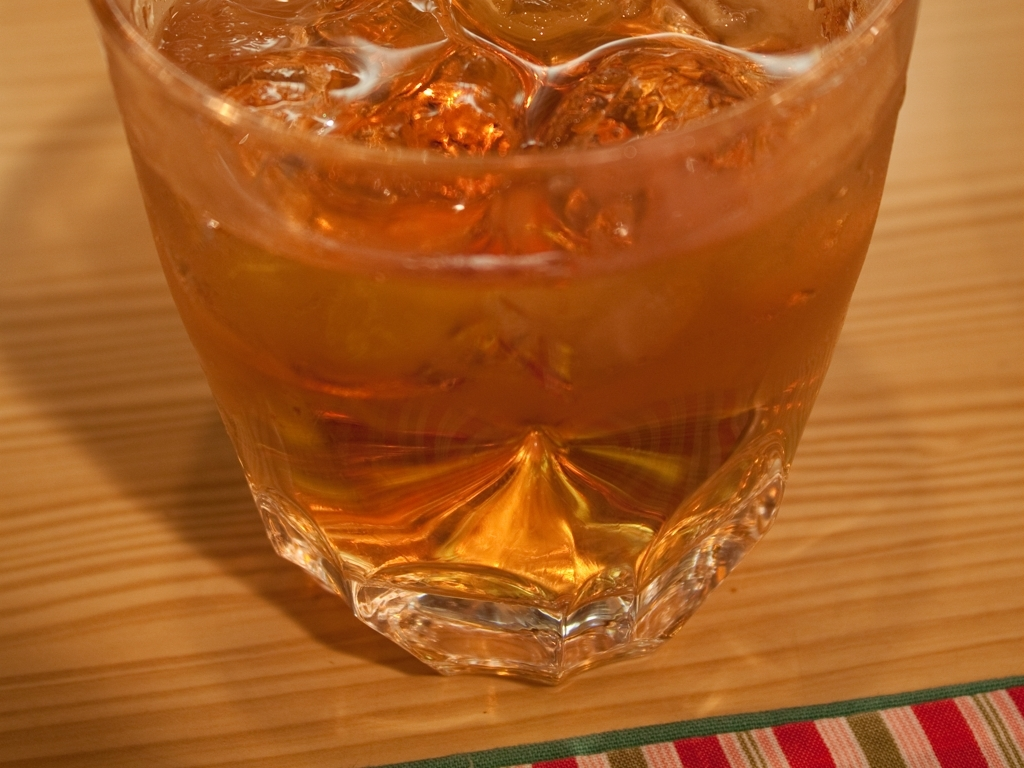Is the glass cup clear?
A. No
B. Yes
Answer with the option's letter from the given choices directly.
 A. 